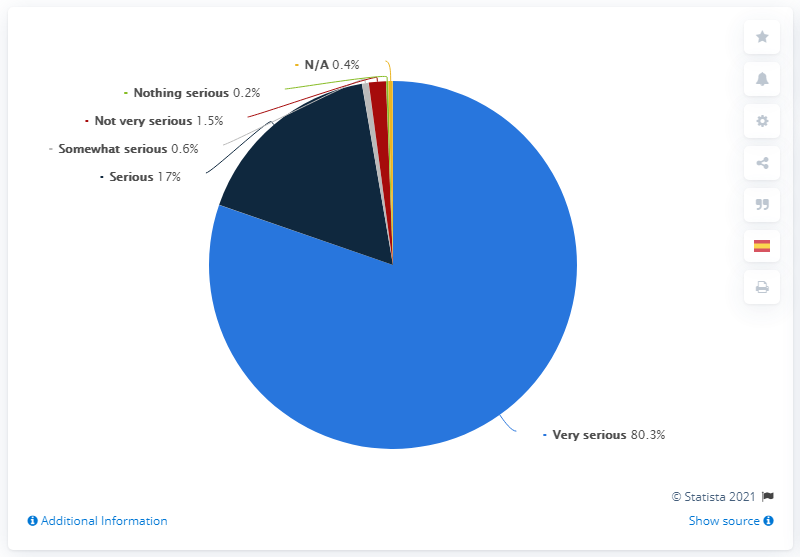Point out several critical features in this image. Out of those who responded, 0.2% think that this is nothing serious. There is a significant difference between those who are extremely serious towards others and the average person, as demonstrated by the difference of 19.7... 